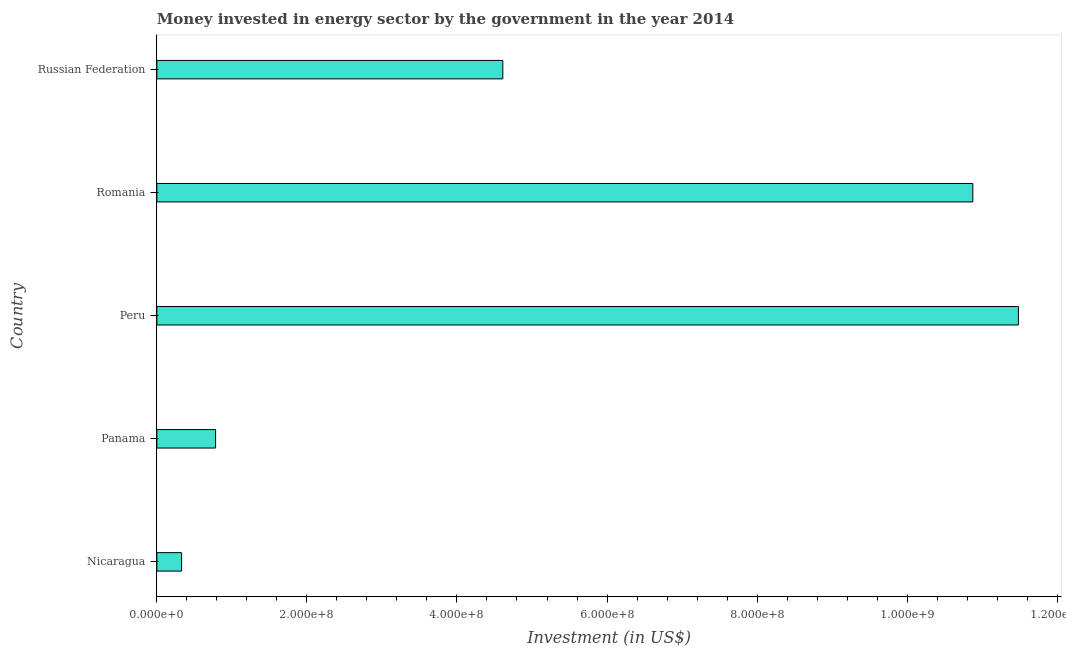Does the graph contain any zero values?
Provide a short and direct response. No. What is the title of the graph?
Ensure brevity in your answer.  Money invested in energy sector by the government in the year 2014. What is the label or title of the X-axis?
Offer a very short reply. Investment (in US$). What is the label or title of the Y-axis?
Provide a succinct answer. Country. What is the investment in energy in Nicaragua?
Your answer should be compact. 3.30e+07. Across all countries, what is the maximum investment in energy?
Make the answer very short. 1.15e+09. Across all countries, what is the minimum investment in energy?
Your answer should be very brief. 3.30e+07. In which country was the investment in energy maximum?
Provide a short and direct response. Peru. In which country was the investment in energy minimum?
Ensure brevity in your answer.  Nicaragua. What is the sum of the investment in energy?
Provide a succinct answer. 2.81e+09. What is the difference between the investment in energy in Panama and Peru?
Provide a short and direct response. -1.07e+09. What is the average investment in energy per country?
Give a very brief answer. 5.62e+08. What is the median investment in energy?
Your answer should be very brief. 4.61e+08. What is the ratio of the investment in energy in Panama to that in Romania?
Offer a terse response. 0.07. Is the difference between the investment in energy in Nicaragua and Romania greater than the difference between any two countries?
Your answer should be very brief. No. What is the difference between the highest and the second highest investment in energy?
Ensure brevity in your answer.  6.08e+07. What is the difference between the highest and the lowest investment in energy?
Make the answer very short. 1.12e+09. How many bars are there?
Ensure brevity in your answer.  5. What is the difference between two consecutive major ticks on the X-axis?
Your response must be concise. 2.00e+08. Are the values on the major ticks of X-axis written in scientific E-notation?
Your answer should be very brief. Yes. What is the Investment (in US$) in Nicaragua?
Provide a short and direct response. 3.30e+07. What is the Investment (in US$) of Panama?
Ensure brevity in your answer.  7.83e+07. What is the Investment (in US$) of Peru?
Ensure brevity in your answer.  1.15e+09. What is the Investment (in US$) in Romania?
Ensure brevity in your answer.  1.09e+09. What is the Investment (in US$) of Russian Federation?
Provide a short and direct response. 4.61e+08. What is the difference between the Investment (in US$) in Nicaragua and Panama?
Provide a succinct answer. -4.53e+07. What is the difference between the Investment (in US$) in Nicaragua and Peru?
Ensure brevity in your answer.  -1.12e+09. What is the difference between the Investment (in US$) in Nicaragua and Romania?
Your answer should be very brief. -1.05e+09. What is the difference between the Investment (in US$) in Nicaragua and Russian Federation?
Provide a succinct answer. -4.28e+08. What is the difference between the Investment (in US$) in Panama and Peru?
Offer a terse response. -1.07e+09. What is the difference between the Investment (in US$) in Panama and Romania?
Provide a short and direct response. -1.01e+09. What is the difference between the Investment (in US$) in Panama and Russian Federation?
Keep it short and to the point. -3.83e+08. What is the difference between the Investment (in US$) in Peru and Romania?
Your answer should be very brief. 6.08e+07. What is the difference between the Investment (in US$) in Peru and Russian Federation?
Your response must be concise. 6.87e+08. What is the difference between the Investment (in US$) in Romania and Russian Federation?
Provide a succinct answer. 6.26e+08. What is the ratio of the Investment (in US$) in Nicaragua to that in Panama?
Offer a very short reply. 0.42. What is the ratio of the Investment (in US$) in Nicaragua to that in Peru?
Your response must be concise. 0.03. What is the ratio of the Investment (in US$) in Nicaragua to that in Russian Federation?
Your answer should be compact. 0.07. What is the ratio of the Investment (in US$) in Panama to that in Peru?
Your response must be concise. 0.07. What is the ratio of the Investment (in US$) in Panama to that in Romania?
Ensure brevity in your answer.  0.07. What is the ratio of the Investment (in US$) in Panama to that in Russian Federation?
Keep it short and to the point. 0.17. What is the ratio of the Investment (in US$) in Peru to that in Romania?
Keep it short and to the point. 1.06. What is the ratio of the Investment (in US$) in Peru to that in Russian Federation?
Offer a very short reply. 2.49. What is the ratio of the Investment (in US$) in Romania to that in Russian Federation?
Give a very brief answer. 2.36. 